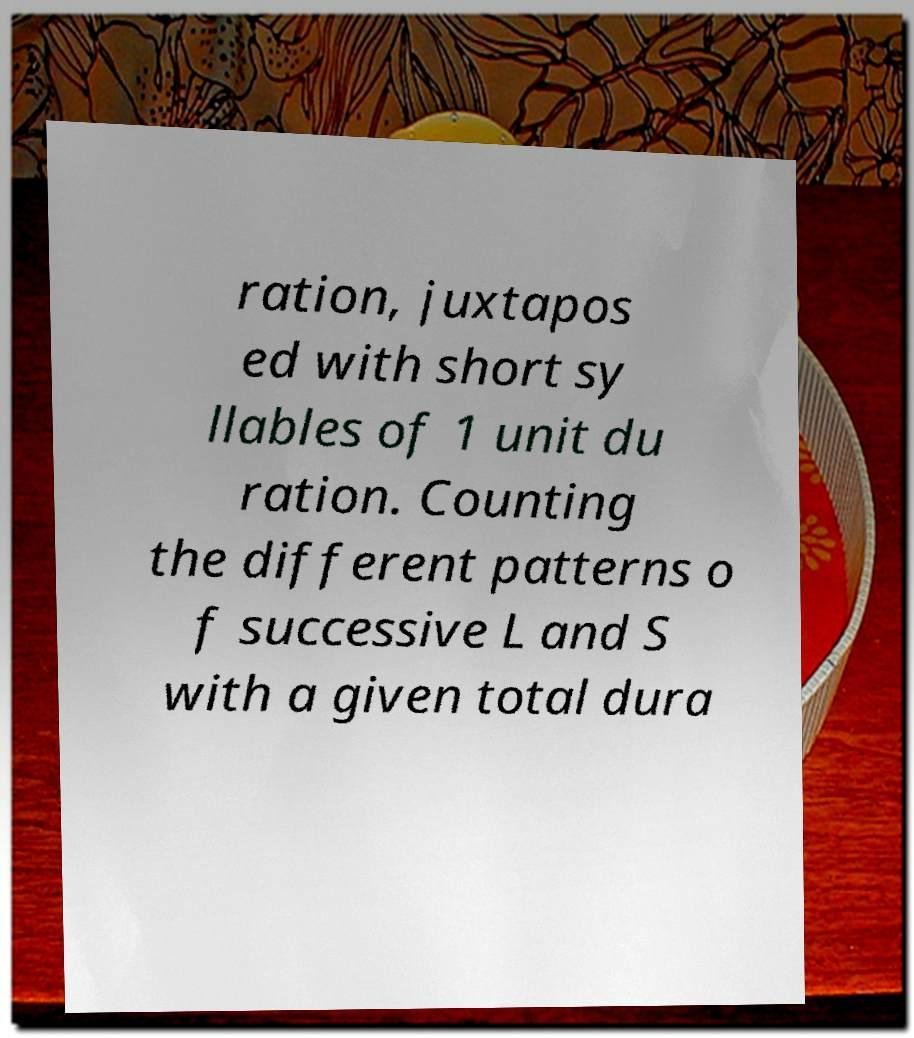What messages or text are displayed in this image? I need them in a readable, typed format. ration, juxtapos ed with short sy llables of 1 unit du ration. Counting the different patterns o f successive L and S with a given total dura 